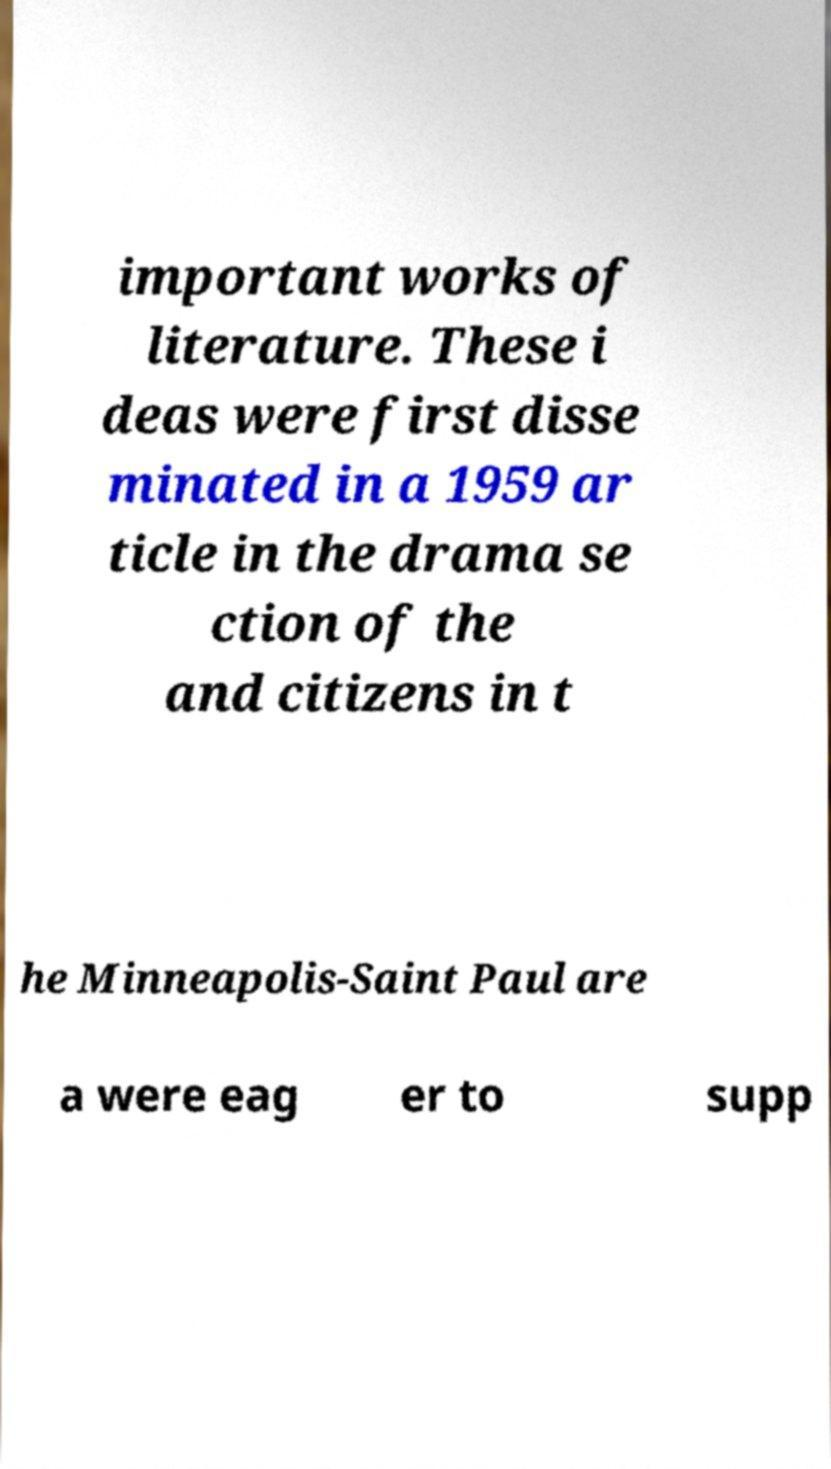Could you extract and type out the text from this image? important works of literature. These i deas were first disse minated in a 1959 ar ticle in the drama se ction of the and citizens in t he Minneapolis-Saint Paul are a were eag er to supp 